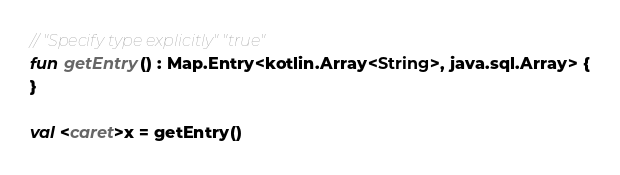Convert code to text. <code><loc_0><loc_0><loc_500><loc_500><_Kotlin_>// "Specify type explicitly" "true"
fun getEntry() : Map.Entry<kotlin.Array<String>, java.sql.Array> {
}

val <caret>x = getEntry()</code> 